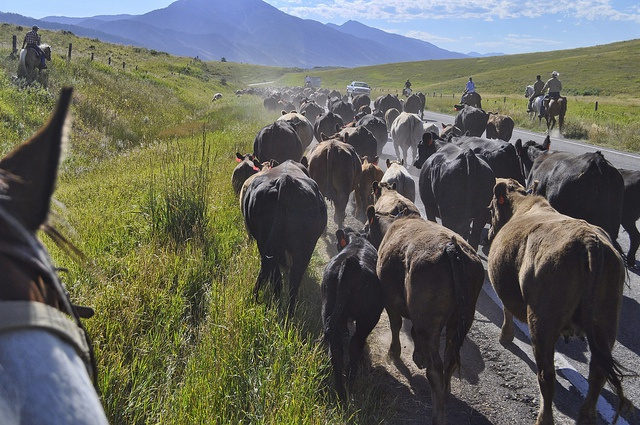Describe the objects in this image and their specific colors. I can see horse in lightblue, black, gray, and darkgray tones, cow in lightblue, black, gray, and darkgray tones, cow in lightblue, black, gray, and darkgray tones, cow in lightblue, gray, darkgray, black, and olive tones, and cow in lightblue, black, darkgray, gray, and darkgreen tones in this image. 